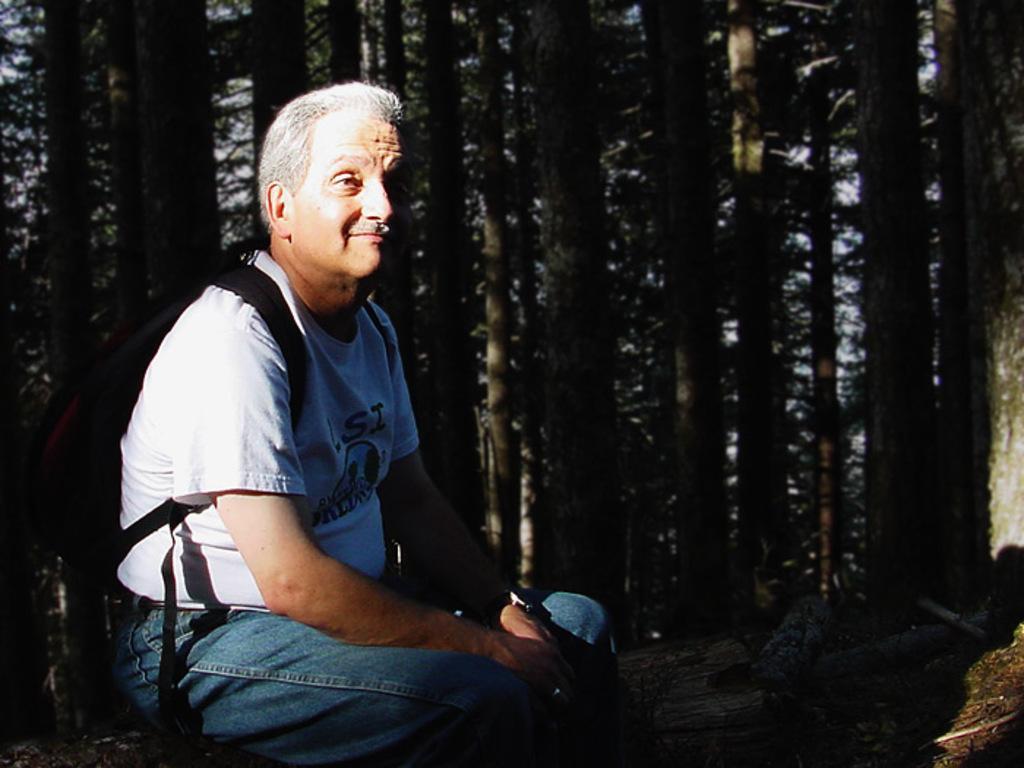Describe this image in one or two sentences. In this picture there is an old man wearing white color t-shirt, cutting and giving a pose into the camera. Behind there are tall trees. 